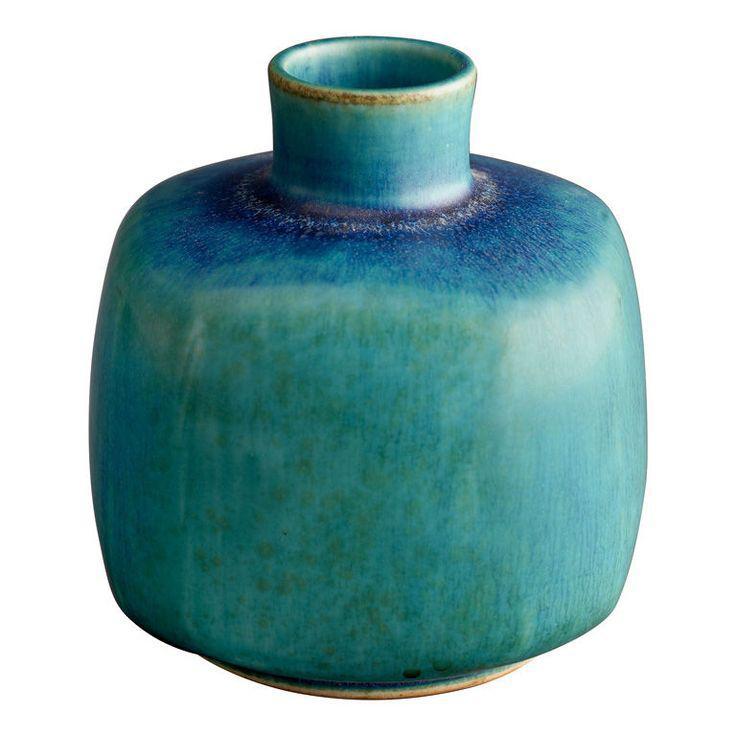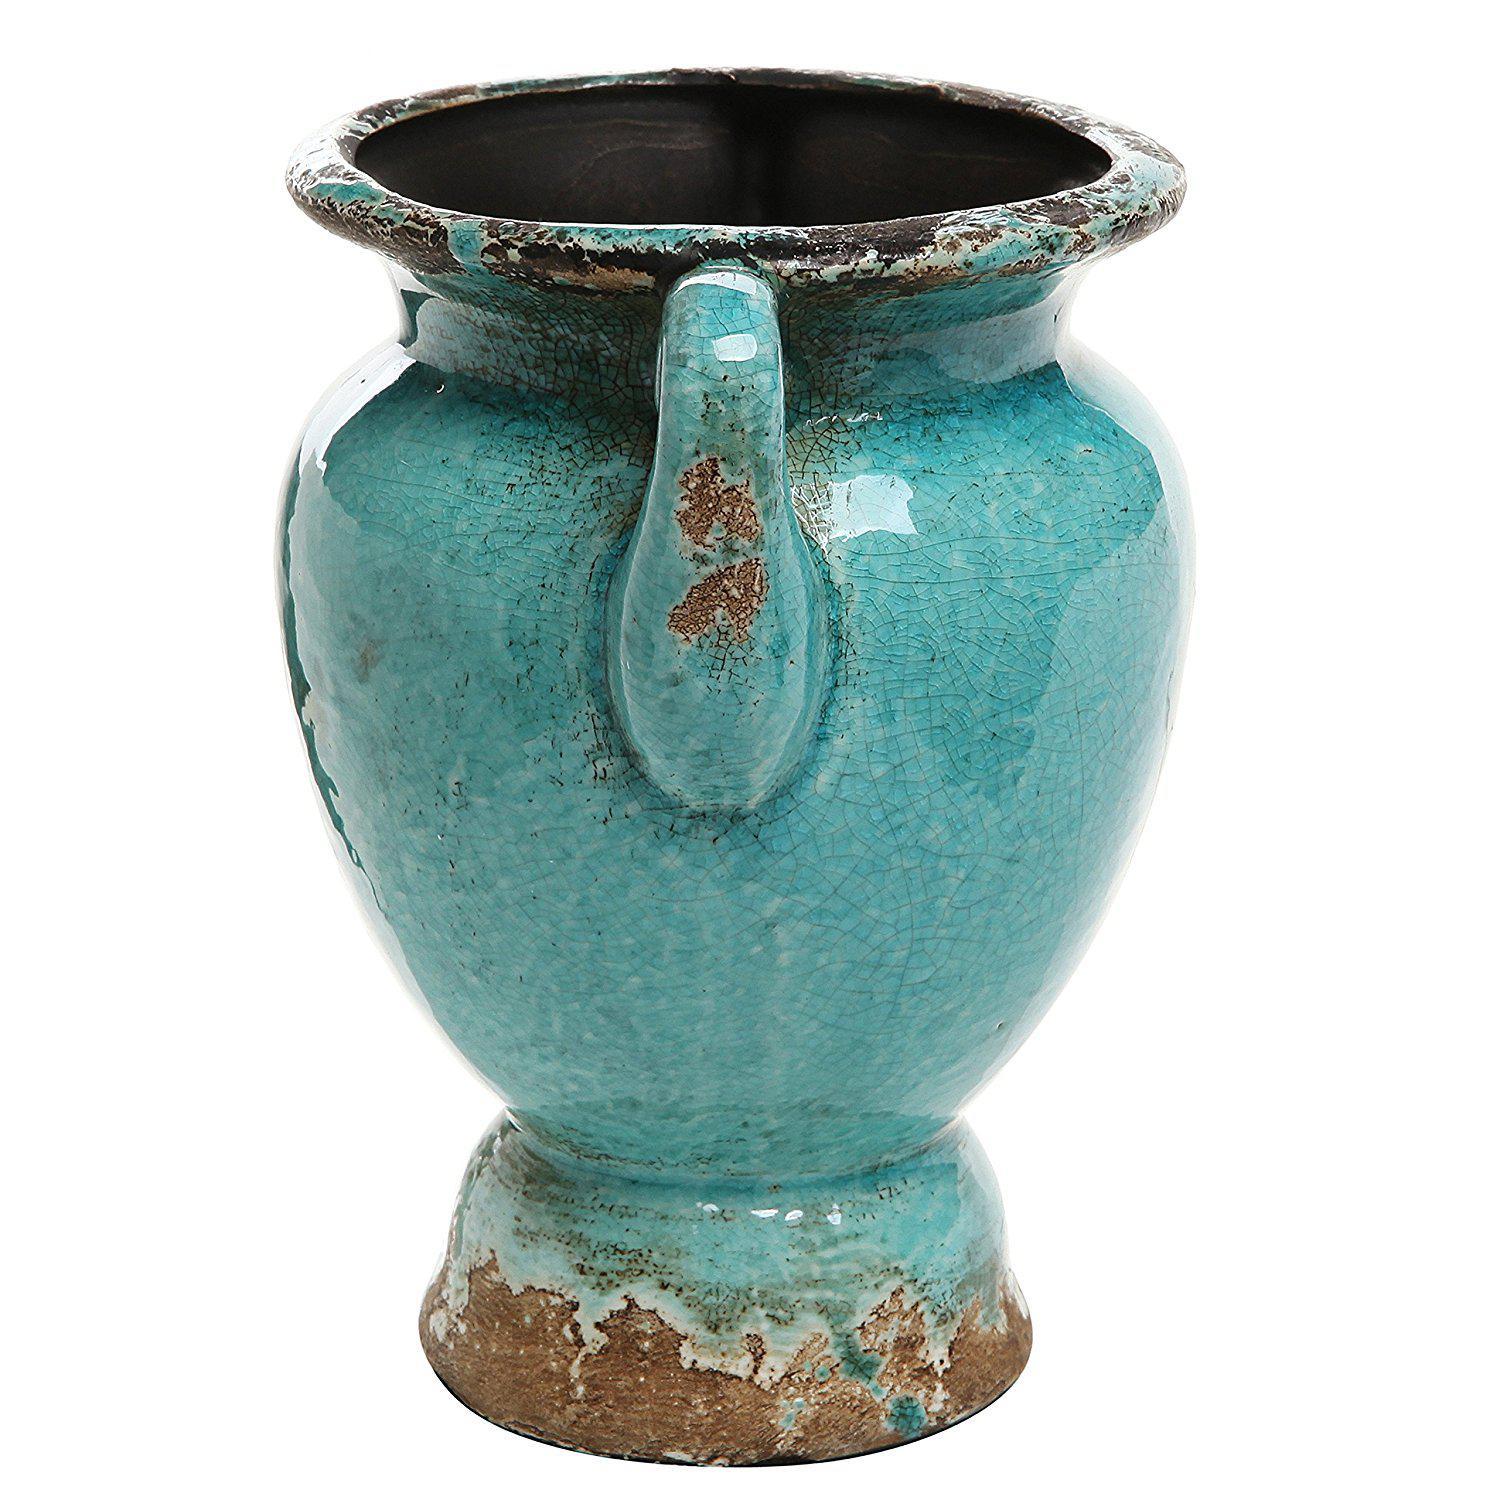The first image is the image on the left, the second image is the image on the right. Assess this claim about the two images: "An image shows three turquoise blue vases.". Correct or not? Answer yes or no. No. The first image is the image on the left, the second image is the image on the right. For the images displayed, is the sentence "Four pieces of turquoise blue pottery are shown." factually correct? Answer yes or no. No. 